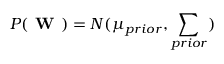<formula> <loc_0><loc_0><loc_500><loc_500>P ( W ) = N ( \mu _ { p r i o r } , \sum _ { p r i o r } )</formula> 